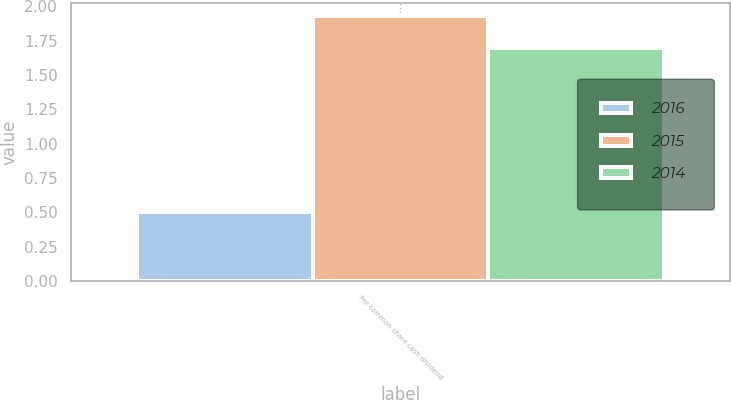<chart> <loc_0><loc_0><loc_500><loc_500><stacked_bar_chart><ecel><fcel>Per common share cash dividend<nl><fcel>2016<fcel>0.5<nl><fcel>2015<fcel>1.93<nl><fcel>2014<fcel>1.7<nl></chart> 